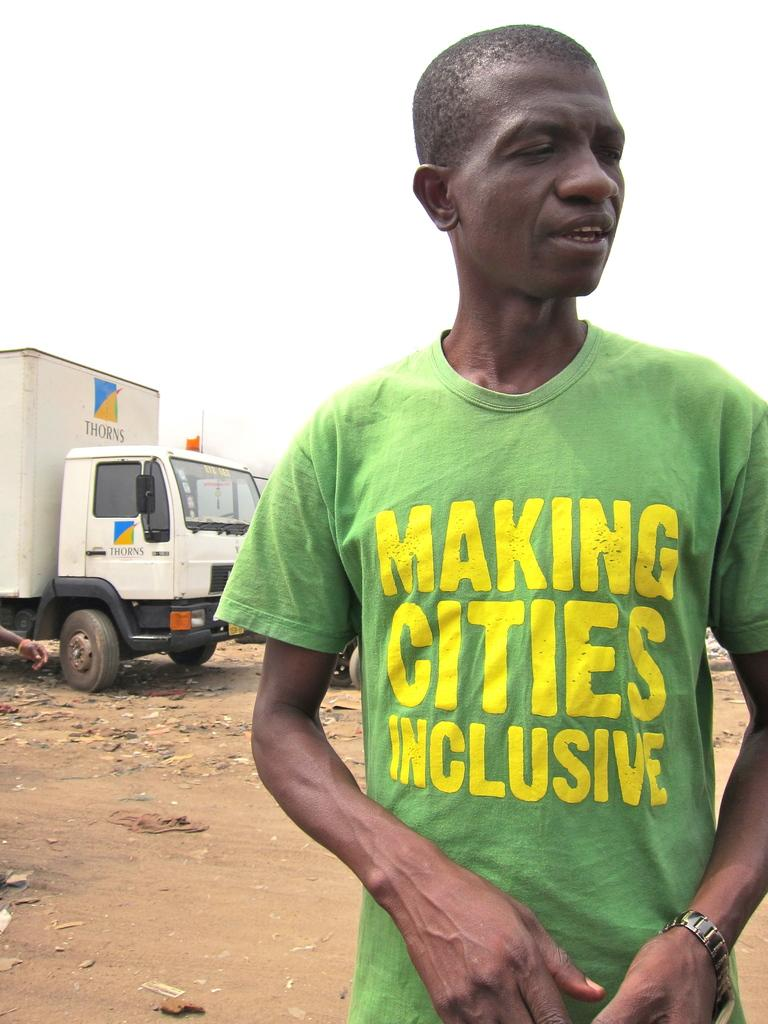What is the main subject of the image? There is a person standing in the image. What else can be seen on the ground in the image? There are vehicles on the ground in the image. What is visible in the background of the image? The sky is visible in the background of the image. Where is the mine located in the image? There is no mine present in the image. What type of animals can be seen at the zoo in the image? There is no zoo present in the image. 